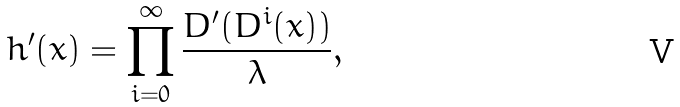<formula> <loc_0><loc_0><loc_500><loc_500>h ^ { \prime } ( x ) = \prod _ { i = 0 } ^ { \infty } \frac { D ^ { \prime } ( D ^ { i } ( x ) ) } { \lambda } ,</formula> 